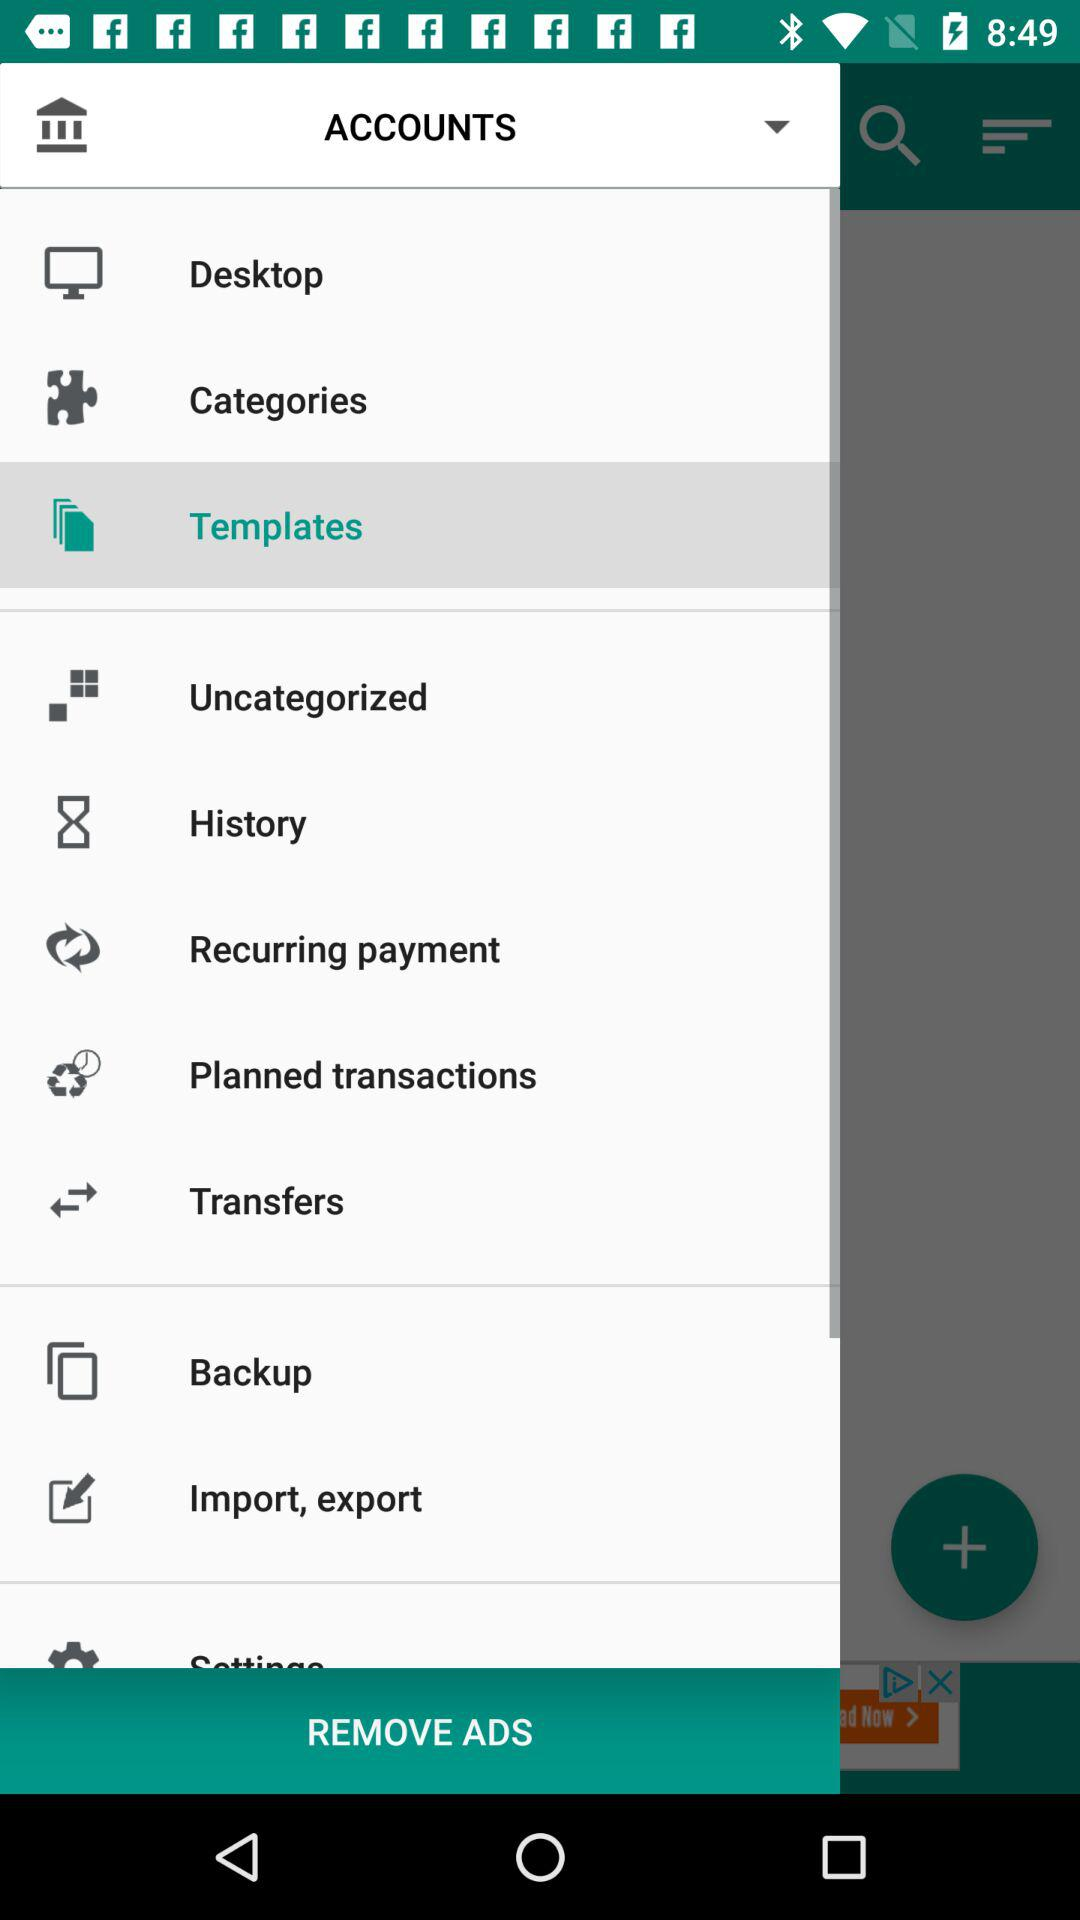Which is the selected option? The selected option is templates. 